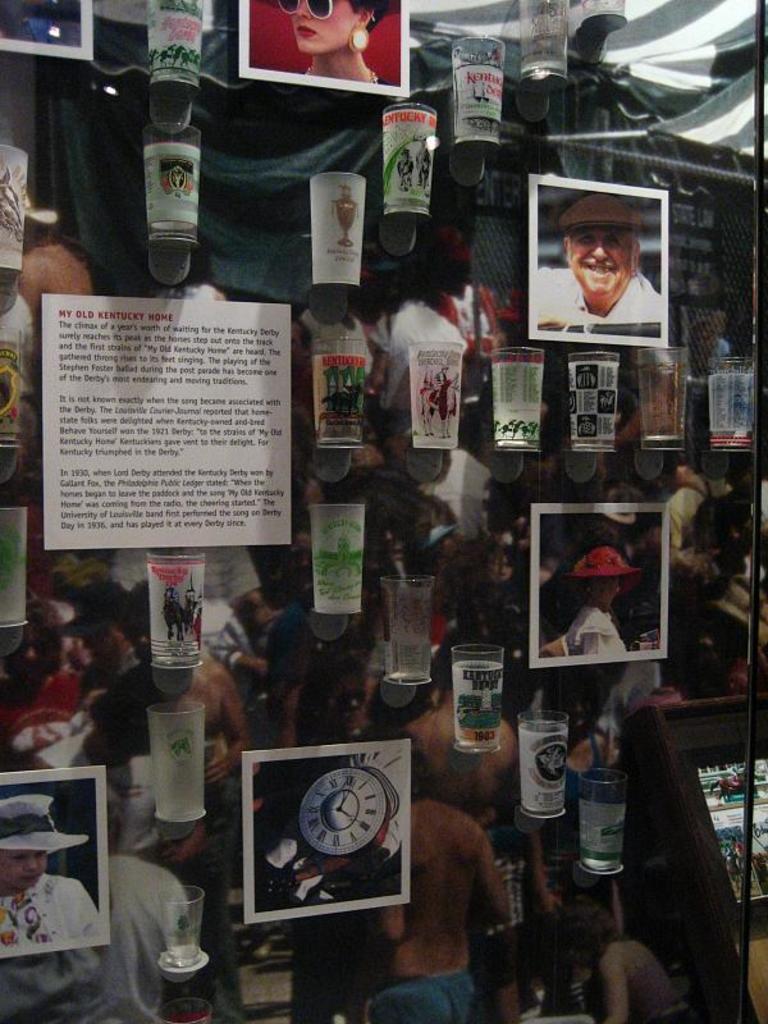Please provide a concise description of this image. In this picture I can see few glasses and in the background I can see pictures of few people on the banner and I can see few photo frames and I can see a board with some text and I can see a metal rod on the right side. 